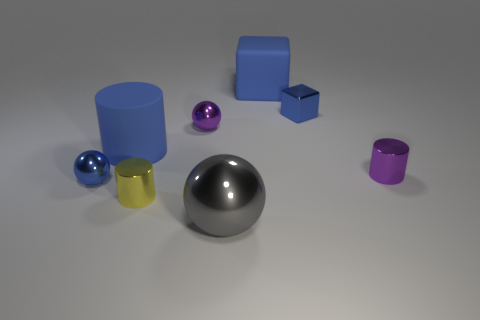What is the big blue object that is to the left of the large gray metal sphere made of?
Offer a terse response. Rubber. What number of small shiny balls are the same color as the rubber block?
Your response must be concise. 1. There is a gray ball that is made of the same material as the small blue ball; what is its size?
Ensure brevity in your answer.  Large. How many things are either small green rubber cubes or yellow objects?
Keep it short and to the point. 1. There is a big block behind the large shiny object; what is its color?
Your answer should be very brief. Blue. There is a purple metal object that is the same shape as the tiny yellow metallic thing; what is its size?
Give a very brief answer. Small. What number of things are either objects that are left of the rubber cylinder or small blue shiny objects that are left of the yellow object?
Your answer should be compact. 1. What size is the sphere that is both in front of the purple sphere and behind the large gray metallic sphere?
Make the answer very short. Small. There is a gray metallic object; is it the same shape as the purple thing on the left side of the tiny purple shiny cylinder?
Keep it short and to the point. Yes. How many objects are metal spheres on the left side of the large metallic thing or purple spheres?
Provide a succinct answer. 2. 